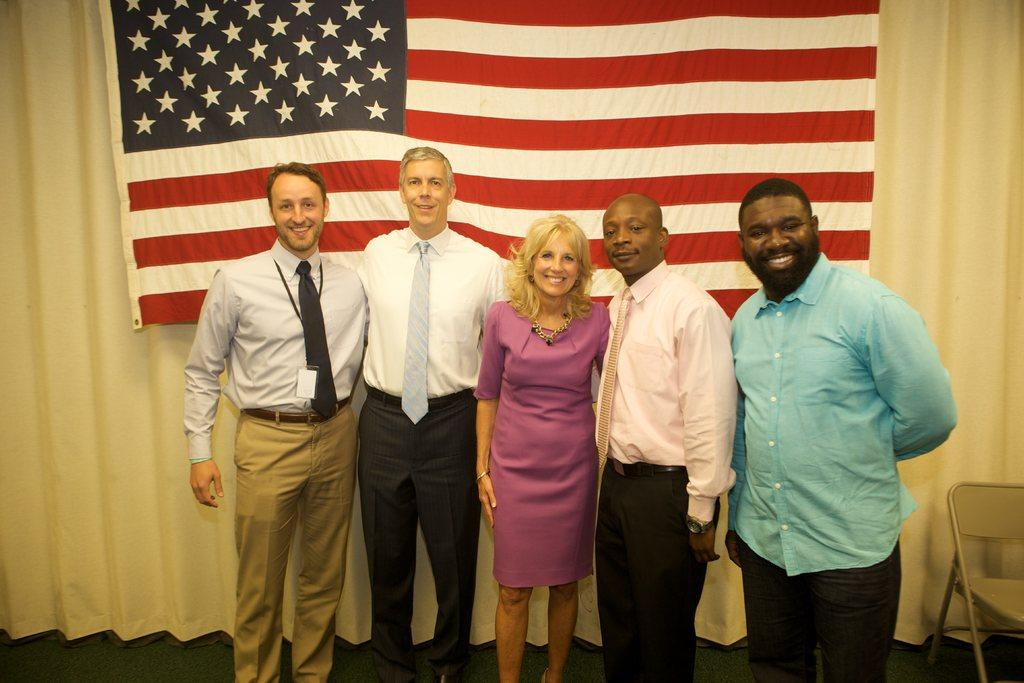How many people are in the image? There is a group of people in the image. What are the people doing in the image? The people are standing in front of a flag and posing for a photo. What is behind the flag in the image? There is a curtain behind the flag. What is the chance of finding a boot in the image? There is no boot present in the image. Does the existence of the flag in the image imply the existence of a country? The presence of a flag in the image does not necessarily imply the existence of a country, as flags can represent various organizations or groups. 